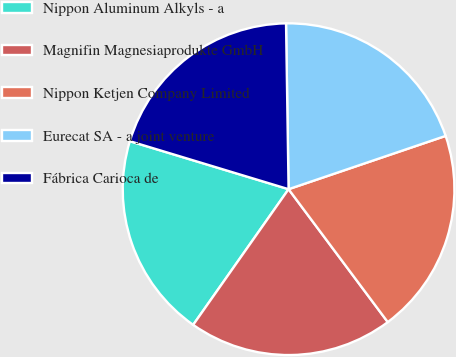Convert chart to OTSL. <chart><loc_0><loc_0><loc_500><loc_500><pie_chart><fcel>Nippon Aluminum Alkyls - a<fcel>Magnifin Magnesiaprodukte GmbH<fcel>Nippon Ketjen Company Limited<fcel>Eurecat SA - a joint venture<fcel>Fábrica Carioca de<nl><fcel>19.92%<fcel>19.96%<fcel>20.0%<fcel>20.04%<fcel>20.08%<nl></chart> 